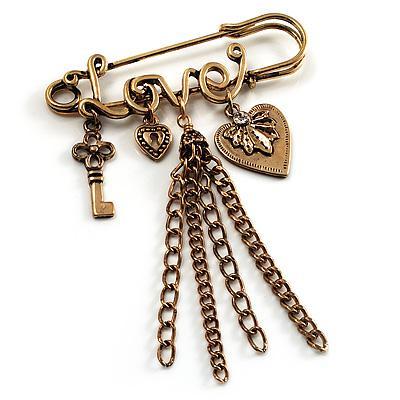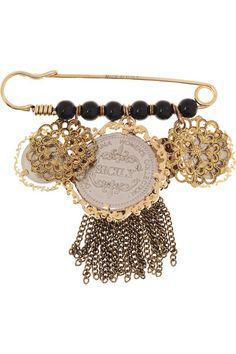The first image is the image on the left, the second image is the image on the right. For the images displayed, is the sentence "There is a heart charm to the right of some other charms." factually correct? Answer yes or no. Yes. The first image is the image on the left, the second image is the image on the right. Assess this claim about the two images: "A gold safety pin is strung with a row of six black beads and suspends a tassel made of chains.". Correct or not? Answer yes or no. Yes. 